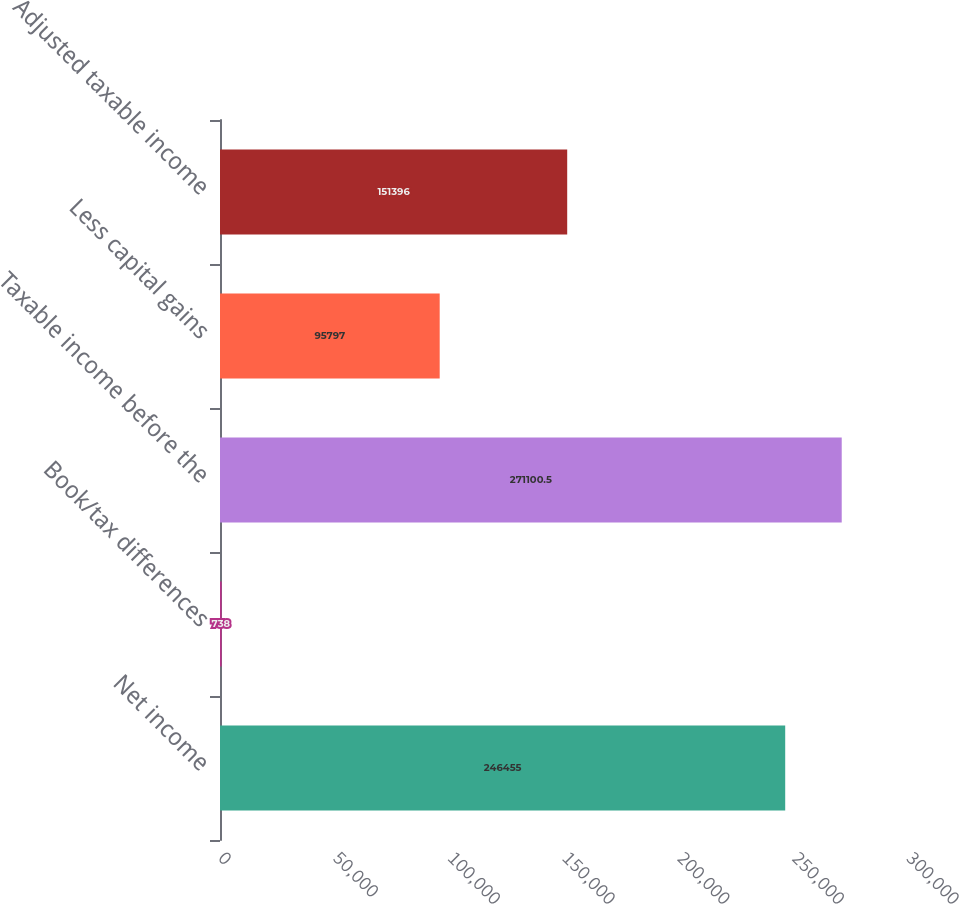Convert chart to OTSL. <chart><loc_0><loc_0><loc_500><loc_500><bar_chart><fcel>Net income<fcel>Book/tax differences<fcel>Taxable income before the<fcel>Less capital gains<fcel>Adjusted taxable income<nl><fcel>246455<fcel>738<fcel>271100<fcel>95797<fcel>151396<nl></chart> 